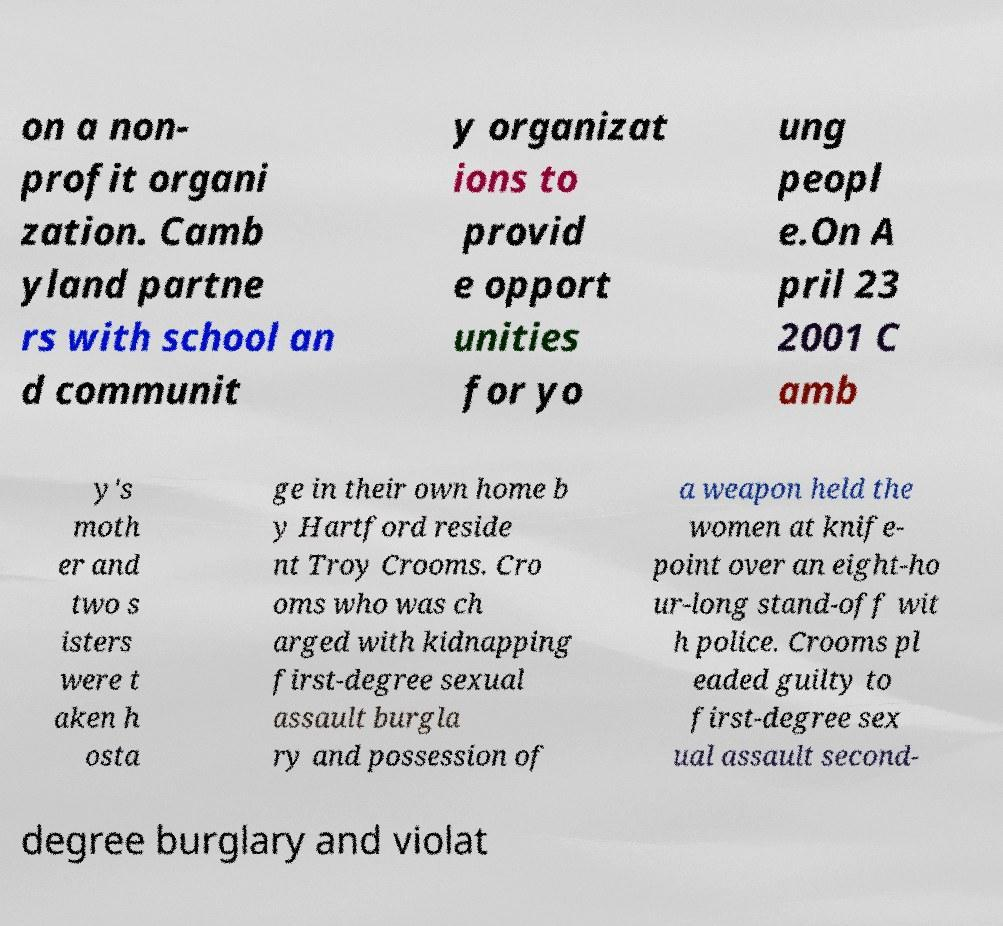Please read and relay the text visible in this image. What does it say? on a non- profit organi zation. Camb yland partne rs with school an d communit y organizat ions to provid e opport unities for yo ung peopl e.On A pril 23 2001 C amb y's moth er and two s isters were t aken h osta ge in their own home b y Hartford reside nt Troy Crooms. Cro oms who was ch arged with kidnapping first-degree sexual assault burgla ry and possession of a weapon held the women at knife- point over an eight-ho ur-long stand-off wit h police. Crooms pl eaded guilty to first-degree sex ual assault second- degree burglary and violat 